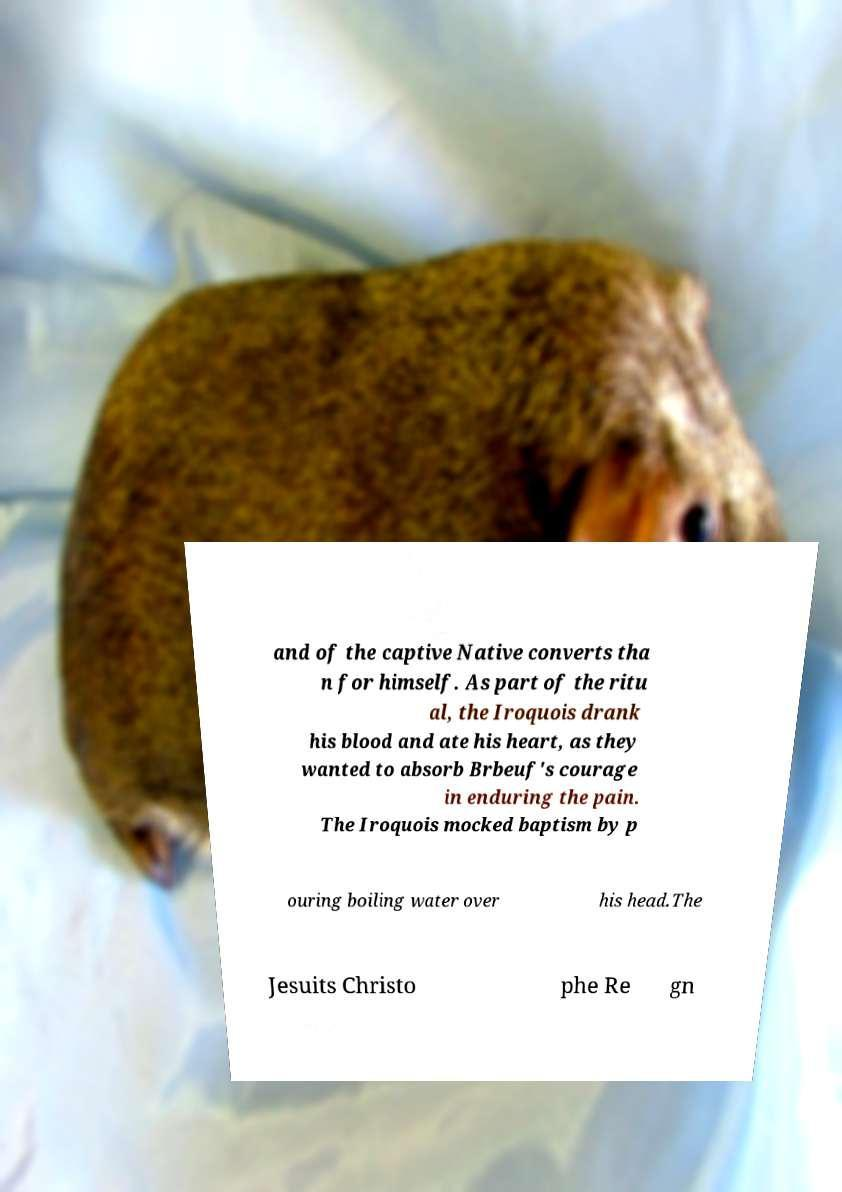There's text embedded in this image that I need extracted. Can you transcribe it verbatim? and of the captive Native converts tha n for himself. As part of the ritu al, the Iroquois drank his blood and ate his heart, as they wanted to absorb Brbeuf's courage in enduring the pain. The Iroquois mocked baptism by p ouring boiling water over his head.The Jesuits Christo phe Re gn 